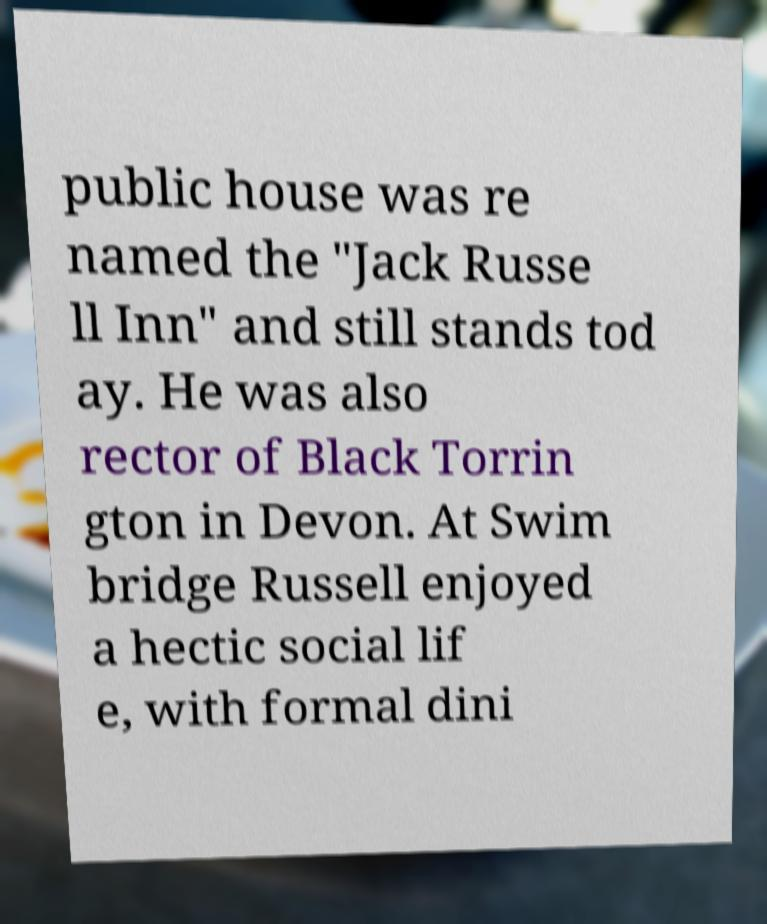Could you extract and type out the text from this image? public house was re named the "Jack Russe ll Inn" and still stands tod ay. He was also rector of Black Torrin gton in Devon. At Swim bridge Russell enjoyed a hectic social lif e, with formal dini 